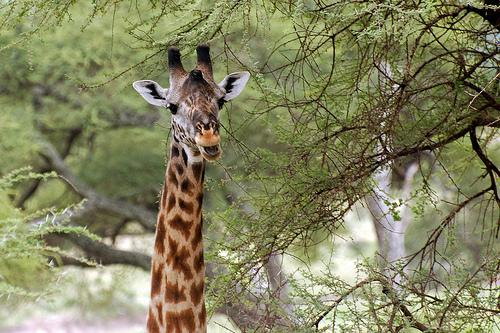What is the appearance of the giraffe's ears and eyes? The giraffe's ears are pointed, and its eyes are open and black. Provide a brief overview of the scene depicted in the image. A single giraffe is standing amid tree limbs, eating with its mouth open and surrounded by trees, during daylight in an outdoor setting. Describe the environment where the picture was taken. The picture was taken outdoors, during the day, in a wooded area with tree limbs, spindly branches, green and brown leaves, and a large wooden tree trunk. List the main features of the giraffe in the image. The giraffe has two eyes, two ears, two horns, a long neck, an open mouth, brown spots, and a brown and tan coloration. Identify the different types of vegetation in the image. There are green leaves on the left, two wooden branches in the background, brown dying leaves on branches, and a large wooden tree trunk. What is the primary activity the giraffe is engaged in? The primary activity the giraffe is engaged in is eating. What time of day and setting is the image likely taken in? The image is likely taken during the day in an outdoor, wooded setting. In what position is the giraffe and how many spots does it have? The giraffe is standing and has multiple brown spots all over its body. How many giraffe horns are visible in the image? Two giraffe horns are visible in the image. Analyze the interaction of the giraffe with its surroundings. The giraffe is interacting with its surroundings by standing among tree limbs and eating from the vegetation, surrounded by trees. What is the giraffe doing with its mouth? The giraffe's mouth is slightly opened, possibly eating. What colors are the spots on the giraffe's body? Brown and tan Identify the animal based on the following description: it has a long neck, brown spots, two ears, and two horns. Giraffe Describe the giraffe's ears. The giraffe has two pointed ears. Is the giraffe's mouth closed tightly? The image contains captions that mention the giraffe's mouth is open, but none of them mention it being closed tightly. Does the giraffe have two horns or three? Select the correct option. a) Two horns b) Three horns a) Two horns In your own words, describe the main object in the image and its surroundings. A single giraffe with pointed ears, open eyes, and an opened mouth is standing amid green and brown leaves and spindly tree limbs during the day. Is the giraffe lying down? The image contains captions stating the giraffe is standing, but none of them mention it lying down. Are there two giraffes in the picture? The image contains captions mentioning a single giraffe, but none of them mention two giraffes. What type of environment is this picture taken in? Choose the correct option among the following: a) Indoor b) Outdoor b) Outdoor Are the giraffe's eyes open or closed? Open What do the branches in the background of the image look like? Spindly and brown with dying leaves List the objects seen in the background of the image. Tree limbs, green leaves, brown dying leaves, wooden branches, and a large wooden tree trunk Describe the scene of the image in a poetic way. Amid spindly limbs of trees, a gentle giant roams with brown spots and curious eyes, reaching for emerald leaves with a long and graceful neck. Briefly describe the setting of the image. Picture taken outdoors during the day, with trees around the giraffe. Where is the giraffe standing in the image? (amid) Trees and branches Are there any distinctive features on the giraffe's head apart from its ears and eyes? Two horns Does the giraffe have no spots? The image contains several captions about the giraffe having brown spots, but none of them mention it has no spots. Is the picture taken at night? The image contains captions saying the picture is taken during the day, but none of them mention it being taken at night. What kind of tree parts can be seen in the image? Leaves, branches, and limbs Are the giraffe's eyes blue? The image contains captions stating the giraffe's eyes are black, but none of them mention blue eyes. Is the giraffe alone or with other giraffes? Alone Is the picture taken during daytime or nighttime? Select the correct option: a) Daytime b) Nighttime a) Daytime 